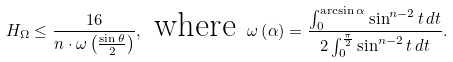Convert formula to latex. <formula><loc_0><loc_0><loc_500><loc_500>H _ { \Omega } \leq \frac { 1 6 } { n \cdot \omega \left ( \frac { \sin \theta } { 2 } \right ) } , \text { where } \omega \left ( \alpha \right ) = \frac { \int _ { 0 } ^ { \arcsin \alpha } \sin ^ { n - 2 } t \, d t } { 2 \int _ { 0 } ^ { \frac { \pi } { 2 } } \sin ^ { n - 2 } t \, d t } .</formula> 